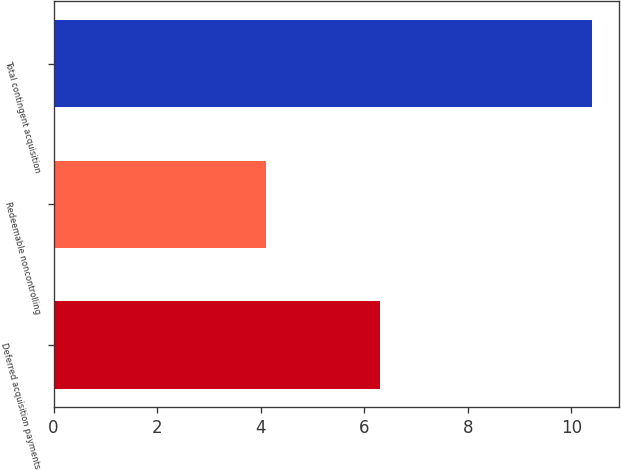Convert chart to OTSL. <chart><loc_0><loc_0><loc_500><loc_500><bar_chart><fcel>Deferred acquisition payments<fcel>Redeemable noncontrolling<fcel>Total contingent acquisition<nl><fcel>6.3<fcel>4.1<fcel>10.4<nl></chart> 